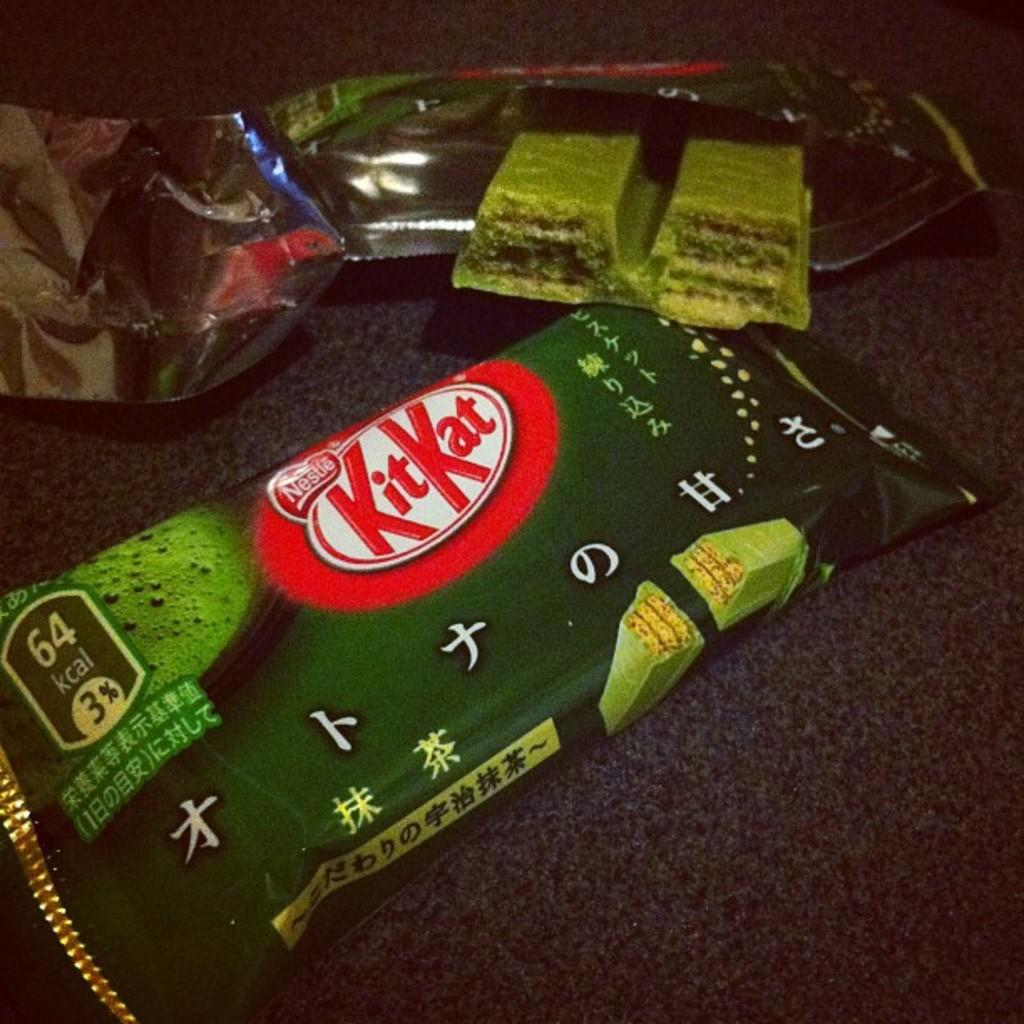What type of chocolate is shown in the image? There are two KitKat chocolates in the image. Are both KitKat packets closed or opened? One of the KitKat packets is opened. Where are the chocolates placed in the image? The chocolates are on a platform. What type of stick can be seen creating friction on the chocolates in the image? There is no stick or friction present in the image; the chocolates are simply placed on a platform. 